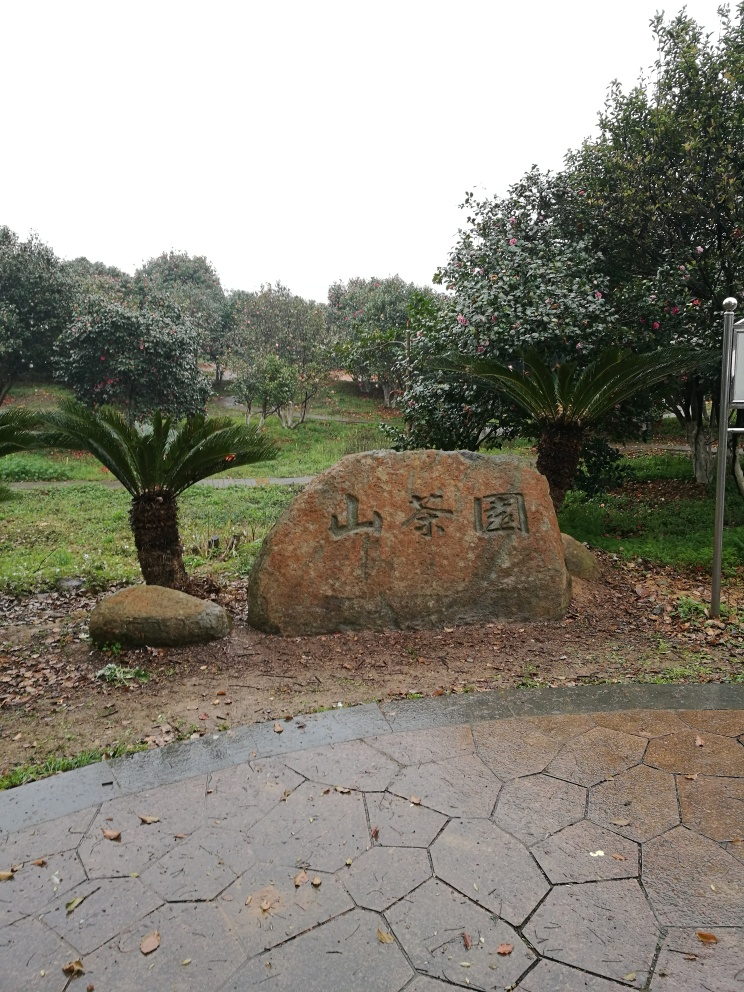Is the overall clarity of the image good? The image is reasonably clear, with no significant blur or distortion. It effectively showcases the large inscribed stone in the foreground, surrounded by trees and vegetation. However, the overcast sky and flat lighting could reduce the contrast and vibrancy of the colors, slightly impacting the visual appeal. 